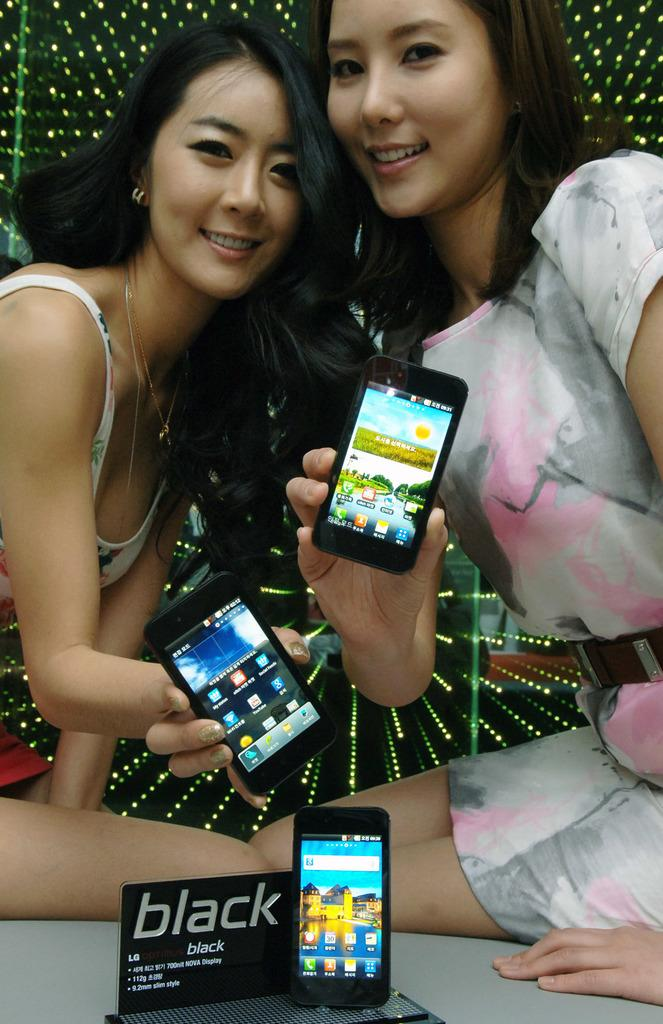<image>
Describe the image concisely. Two women hold up black LG phones for an ad. 